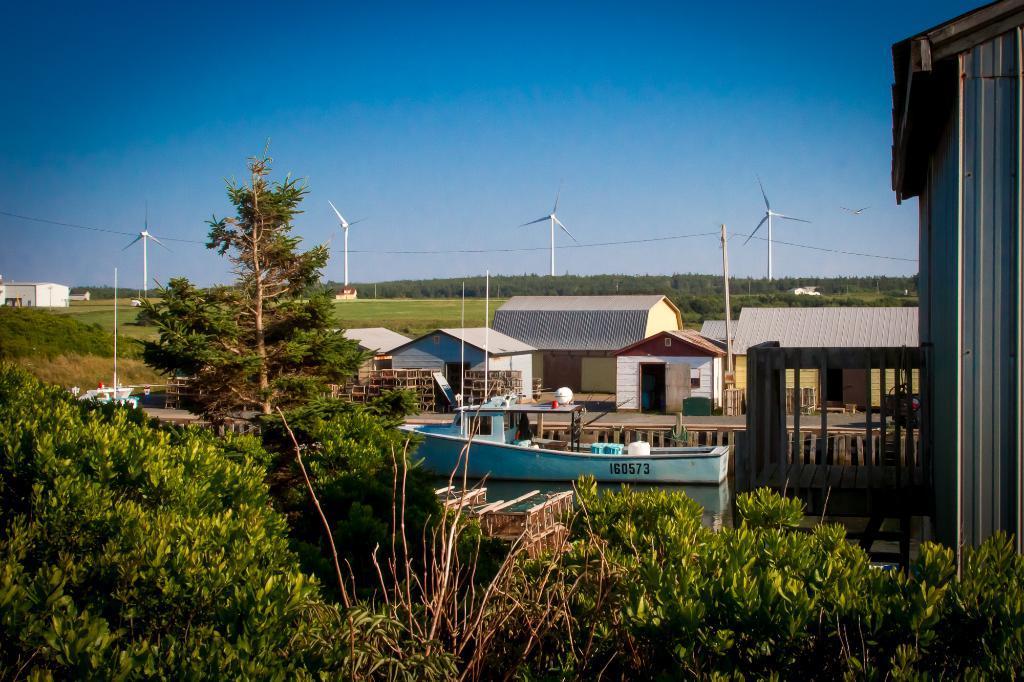How would you summarize this image in a sentence or two? In the foreground of the image we can see some trees, there are some houses and in the background of the image there are some windmills, trees and there are also some houses and there is clear sky. 